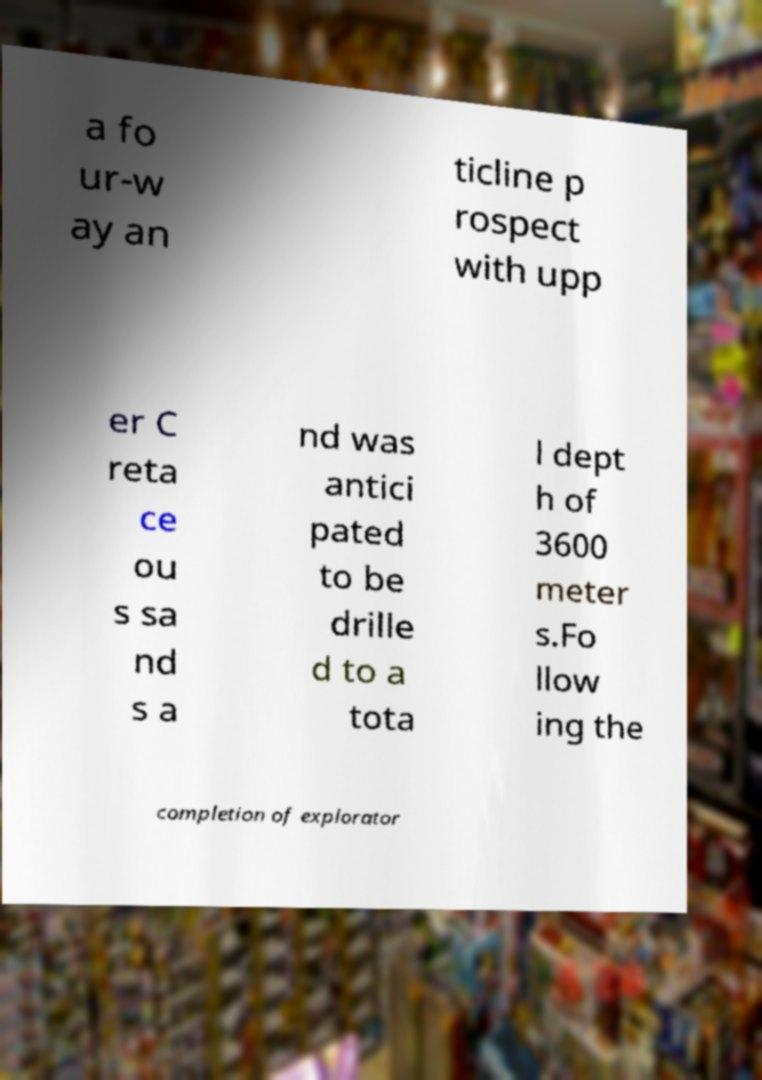There's text embedded in this image that I need extracted. Can you transcribe it verbatim? a fo ur-w ay an ticline p rospect with upp er C reta ce ou s sa nd s a nd was antici pated to be drille d to a tota l dept h of 3600 meter s.Fo llow ing the completion of explorator 